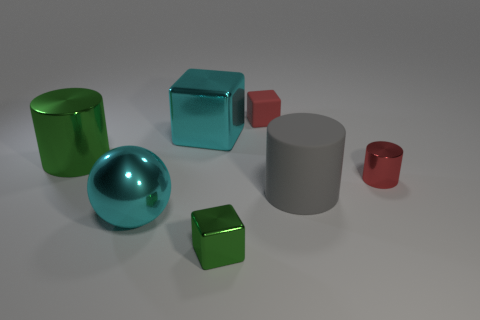Subtract all green shiny cylinders. How many cylinders are left? 2 Add 1 small green shiny cubes. How many objects exist? 8 Subtract all balls. How many objects are left? 6 Subtract 1 blocks. How many blocks are left? 2 Subtract all yellow cylinders. Subtract all gray balls. How many cylinders are left? 3 Subtract all yellow cylinders. How many brown blocks are left? 0 Subtract all small cyan matte spheres. Subtract all gray cylinders. How many objects are left? 6 Add 4 small red rubber things. How many small red rubber things are left? 5 Add 6 large matte cylinders. How many large matte cylinders exist? 7 Subtract all cyan blocks. How many blocks are left? 2 